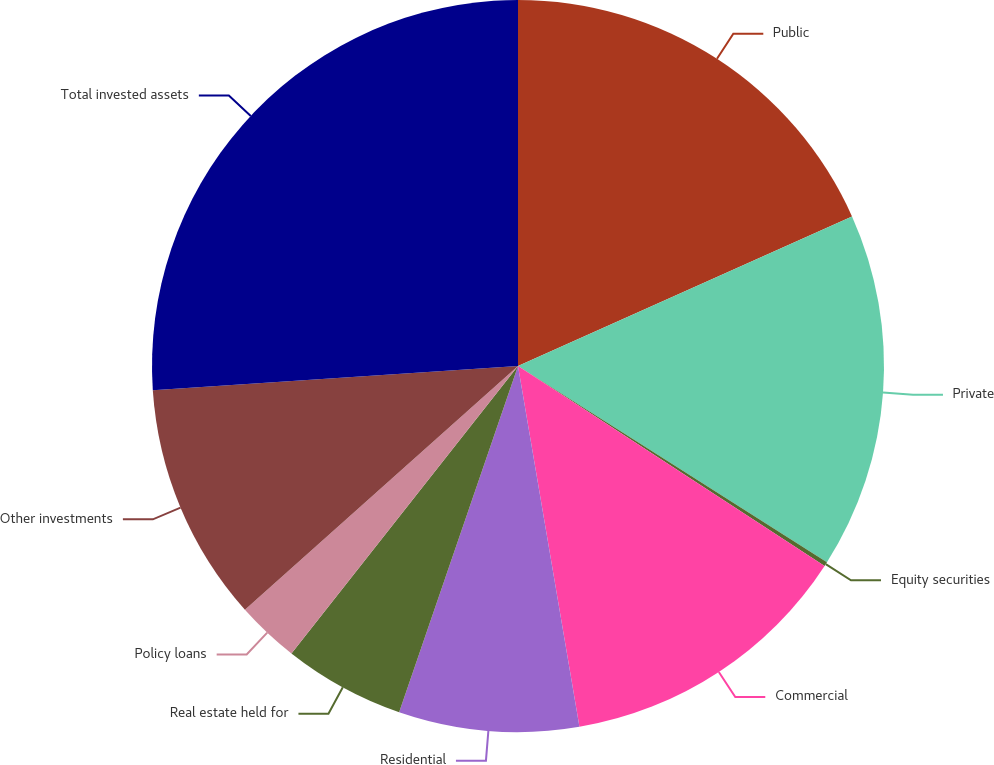Convert chart. <chart><loc_0><loc_0><loc_500><loc_500><pie_chart><fcel>Public<fcel>Private<fcel>Equity securities<fcel>Commercial<fcel>Residential<fcel>Real estate held for<fcel>Policy loans<fcel>Other investments<fcel>Total invested assets<nl><fcel>18.3%<fcel>15.71%<fcel>0.19%<fcel>13.12%<fcel>7.95%<fcel>5.36%<fcel>2.78%<fcel>10.54%<fcel>26.06%<nl></chart> 